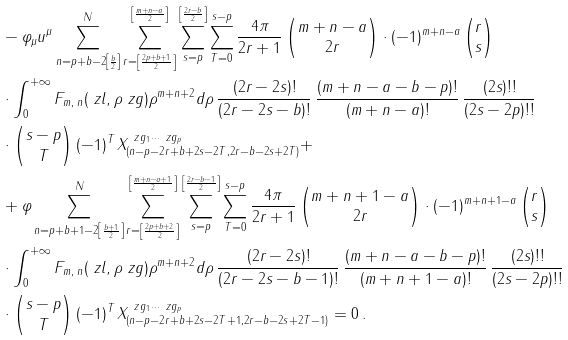Convert formula to latex. <formula><loc_0><loc_0><loc_500><loc_500>& - \varphi _ { \mu } u ^ { \mu } \sum _ { n = p + b - 2 \left [ \frac { b } { 2 } \right ] } ^ { N } \sum _ { r = \left [ \frac { 2 p + b + 1 } { 2 } \right ] } ^ { \left [ \frac { m + n - a } { 2 } \right ] } \sum _ { s = p } ^ { \left [ \frac { 2 r - b } { 2 } \right ] } \sum _ { T = 0 } ^ { s - p } \frac { 4 \pi } { 2 r + 1 } \begin{pmatrix} m + n - a \\ 2 r \end{pmatrix} \cdot ( - 1 ) ^ { m + n - a } \begin{pmatrix} r \\ s \end{pmatrix} \\ & \cdot \int _ { 0 } ^ { + \infty } F _ { m , \, n } ( \ z l , \rho \ z g ) \rho ^ { m + n + 2 } d \rho \, \frac { ( 2 r - 2 s ) ! } { ( 2 r - 2 s - b ) ! } \, \frac { ( m + n - a - b - p ) ! } { ( m + n - a ) ! } \, \frac { ( 2 s ) ! ! } { ( 2 s - 2 p ) ! ! } \\ & \cdot \begin{pmatrix} s - p \\ T \end{pmatrix} ( - 1 ) ^ { T } \, X ^ { \ z g _ { 1 } \cdots \ z g _ { p } } _ { ( n - p - 2 r + b + 2 s - 2 T , 2 r - b - 2 s + 2 T ) } + \\ & + \varphi \sum _ { n = p + b + 1 - 2 \left [ \frac { b + 1 } { 2 } \right ] } ^ { N } \sum _ { r = \left [ \frac { 2 p + b + 2 } { 2 } \right ] } ^ { \left [ \frac { m + n - a + 1 } { 2 } \right ] } \sum _ { s = p } ^ { \left [ \frac { 2 r - b - 1 } { 2 } \right ] } \sum _ { T = 0 } ^ { s - p } \frac { 4 \pi } { 2 r + 1 } \begin{pmatrix} m + n + 1 - a \\ 2 r \end{pmatrix} \cdot ( - 1 ) ^ { m + n + 1 - a } \begin{pmatrix} r \\ s \end{pmatrix} \\ & \cdot \int _ { 0 } ^ { + \infty } F _ { m , \, n } ( \ z l , \rho \ z g ) \rho ^ { m + n + 2 } d \rho \, \frac { ( 2 r - 2 s ) ! } { ( 2 r - 2 s - b - 1 ) ! } \, \frac { ( m + n - a - b - p ) ! } { ( m + n + 1 - a ) ! } \, \frac { ( 2 s ) ! ! } { ( 2 s - 2 p ) ! ! } \\ & \cdot \begin{pmatrix} s - p \\ T \end{pmatrix} ( - 1 ) ^ { T } \, X ^ { \ z g _ { 1 } \cdots \ z g _ { p } } _ { ( n - p - 2 r + b + 2 s - 2 T + 1 , 2 r - b - 2 s + 2 T - 1 ) } = 0 \, .</formula> 